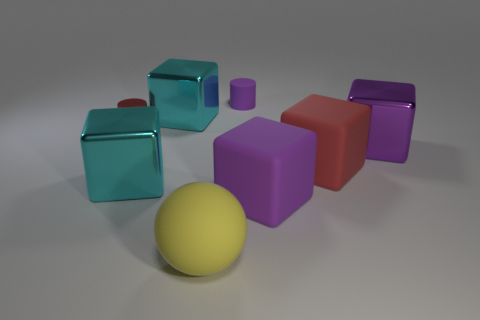There is a small cylinder that is behind the red metallic object; are there any yellow rubber objects that are in front of it?
Make the answer very short. Yes. What is the shape of the tiny purple rubber thing?
Offer a very short reply. Cylinder. The matte block that is the same color as the small metallic thing is what size?
Make the answer very short. Large. There is a metallic block that is right of the cylinder to the right of the big yellow object; what is its size?
Your answer should be compact. Large. What is the size of the shiny block that is to the right of the tiny matte object?
Offer a very short reply. Large. Are there fewer tiny red metal things in front of the big yellow rubber thing than large yellow balls that are on the right side of the small purple rubber cylinder?
Make the answer very short. No. The small rubber cylinder has what color?
Keep it short and to the point. Purple. Is there a ball that has the same color as the tiny metal thing?
Provide a succinct answer. No. What shape is the large metallic thing on the right side of the large yellow matte object that is left of the large red rubber cube in front of the small rubber cylinder?
Offer a terse response. Cube. There is a red object that is left of the tiny purple rubber object; what material is it?
Make the answer very short. Metal. 